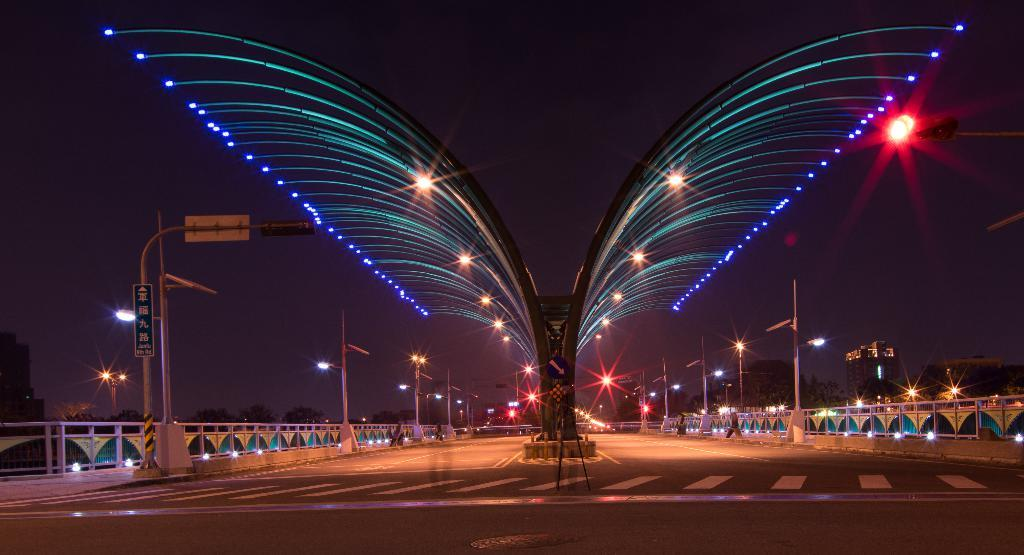What structures are present in the image that have lights on them? There are poles with lights in the image. What type of natural elements can be seen in the background of the image? There are trees in the background of the image. What type of man-made structures are visible in the image? There are buildings in the image. What type of barrier or divider can be seen in the image? There are fence or railings in the image. Can you tell me how many goats are present in the image? There are no goats present in the image. What type of meeting is taking place in the image? There is no meeting depicted in the image. 